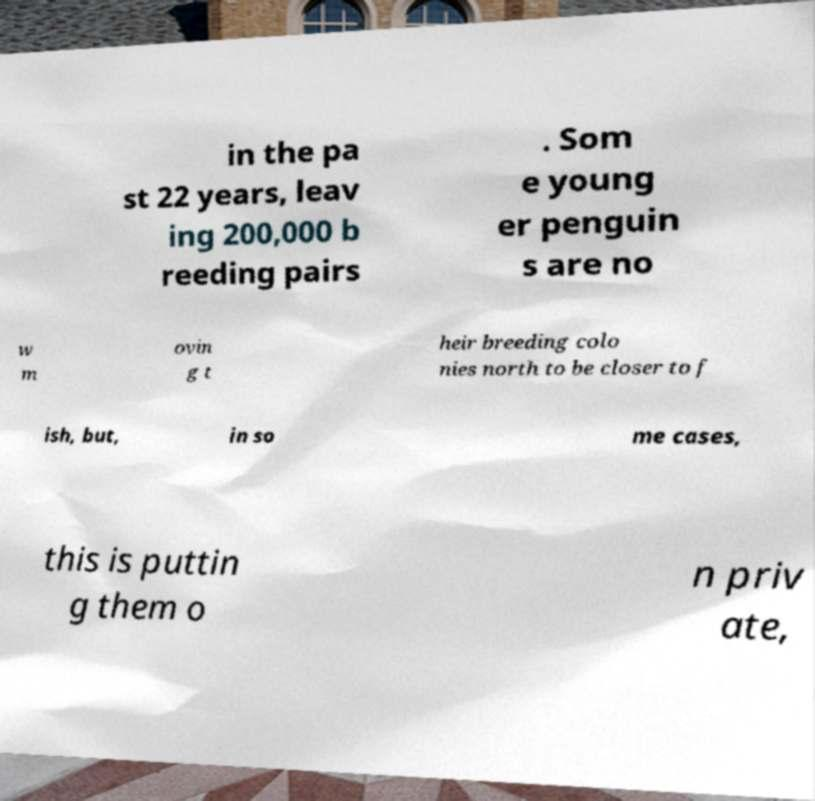Could you assist in decoding the text presented in this image and type it out clearly? in the pa st 22 years, leav ing 200,000 b reeding pairs . Som e young er penguin s are no w m ovin g t heir breeding colo nies north to be closer to f ish, but, in so me cases, this is puttin g them o n priv ate, 